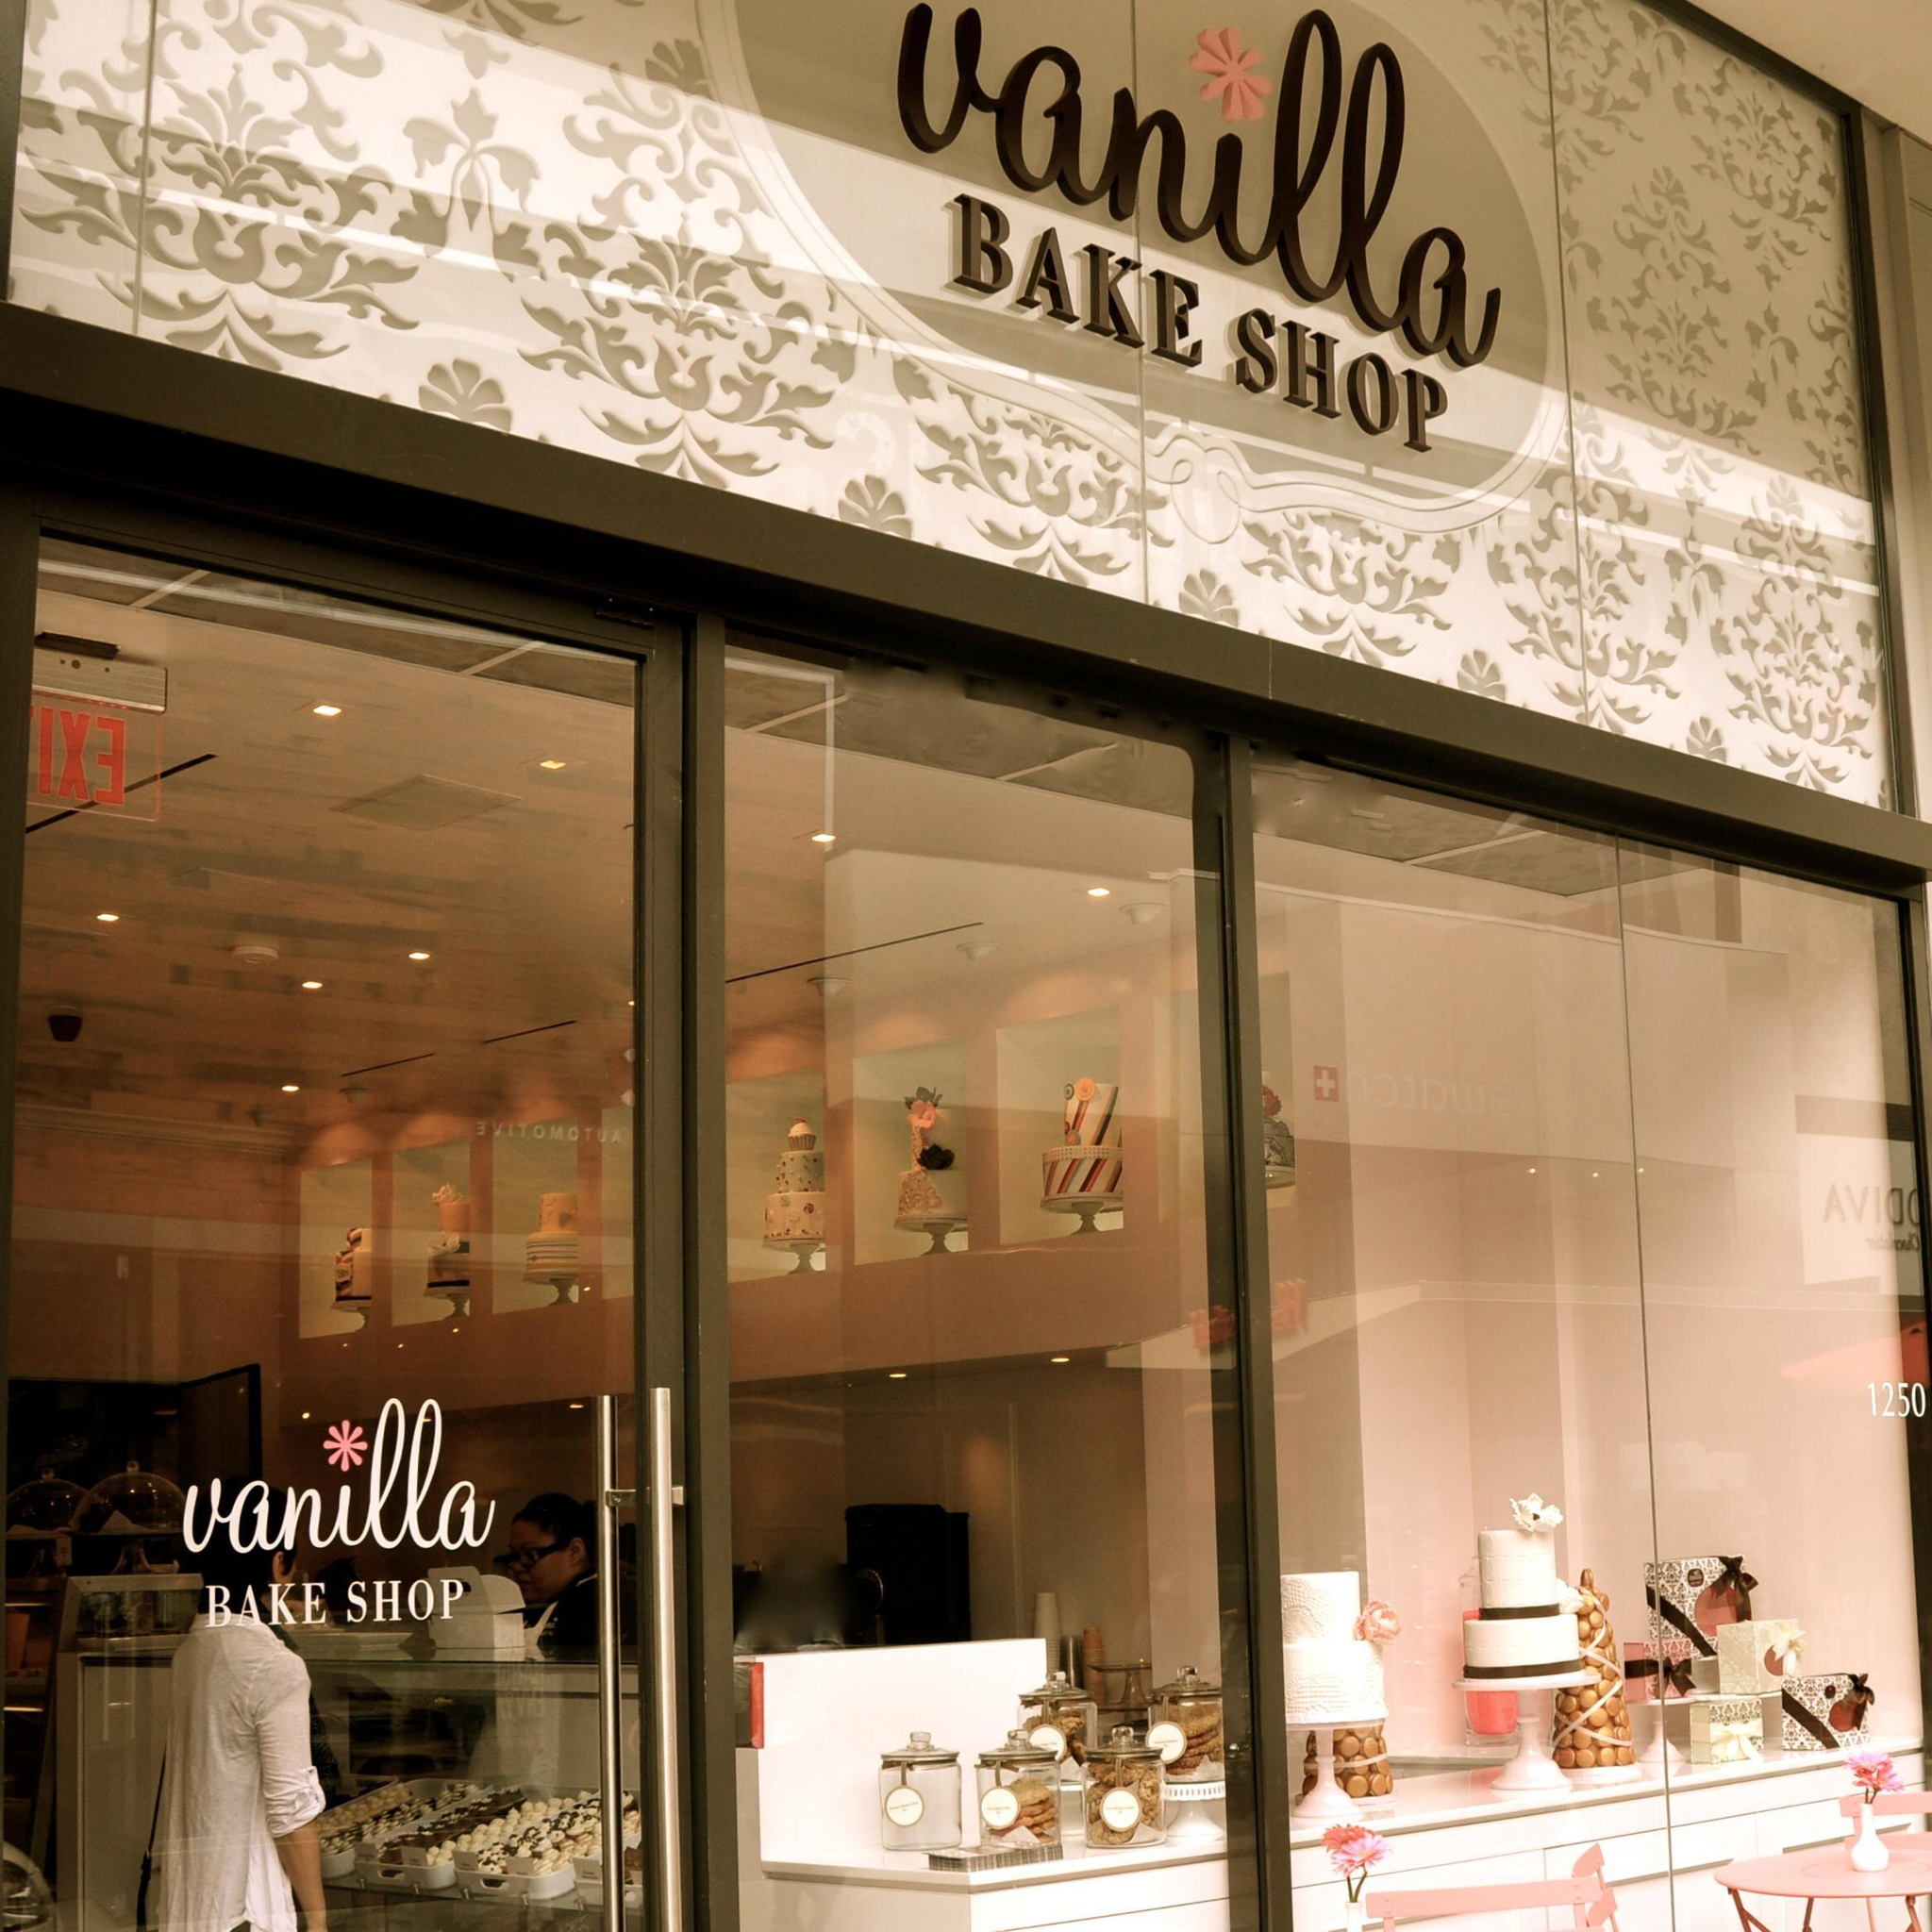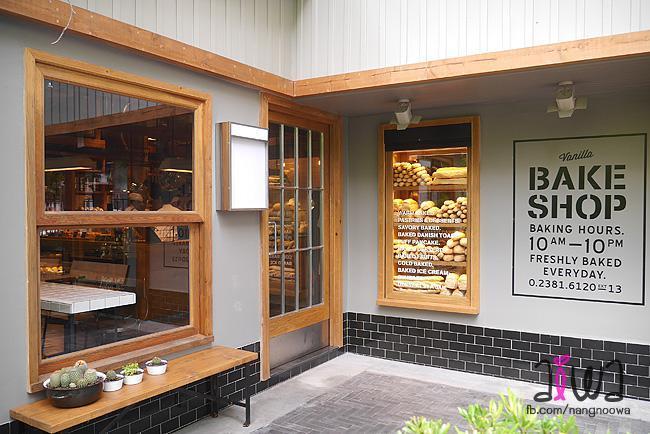The first image is the image on the left, the second image is the image on the right. For the images shown, is this caption "A large table lamp is on top of a brown table next to a display of desserts." true? Answer yes or no. No. The first image is the image on the left, the second image is the image on the right. Given the left and right images, does the statement "There is a lampshade that says """"Vanilla Bake Shop""""" hold true? Answer yes or no. No. 